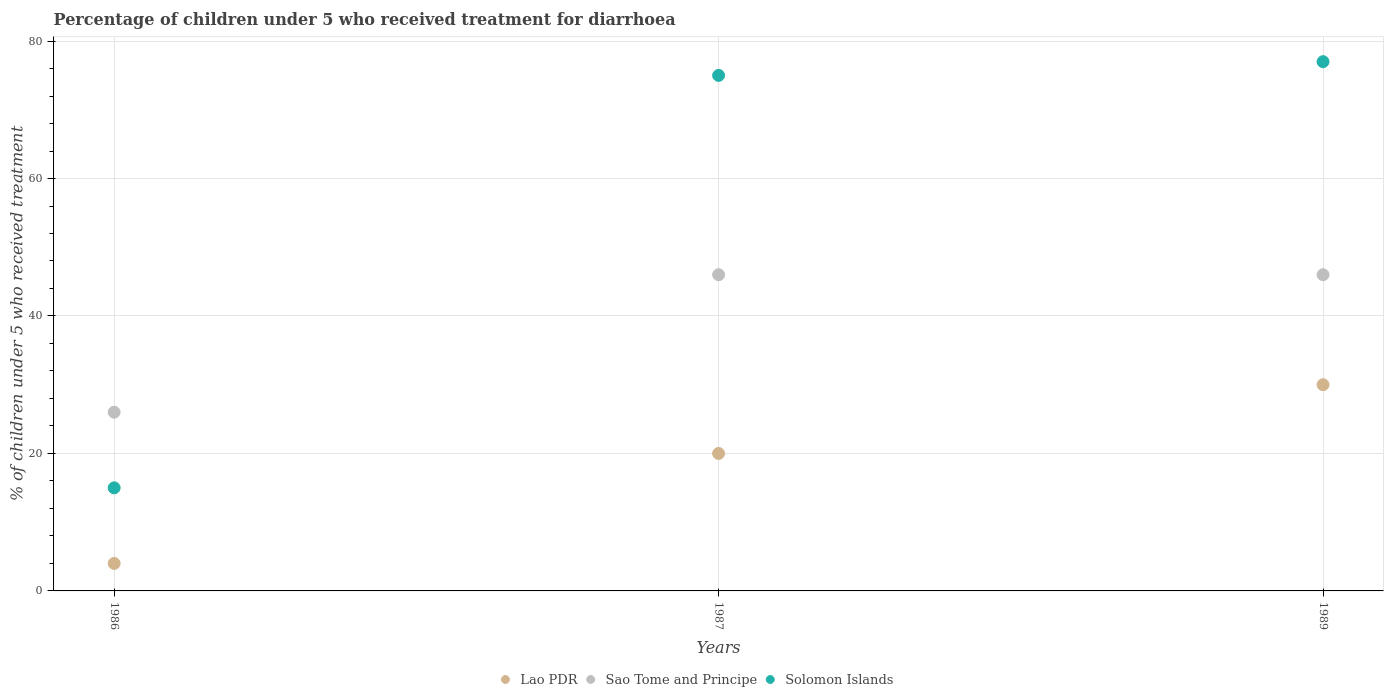How many different coloured dotlines are there?
Ensure brevity in your answer.  3. Is the number of dotlines equal to the number of legend labels?
Make the answer very short. Yes. What is the percentage of children who received treatment for diarrhoea  in Lao PDR in 1986?
Make the answer very short. 4. In which year was the percentage of children who received treatment for diarrhoea  in Sao Tome and Principe minimum?
Give a very brief answer. 1986. What is the total percentage of children who received treatment for diarrhoea  in Solomon Islands in the graph?
Your response must be concise. 167. What is the difference between the percentage of children who received treatment for diarrhoea  in Lao PDR in 1989 and the percentage of children who received treatment for diarrhoea  in Solomon Islands in 1987?
Offer a very short reply. -45. What is the average percentage of children who received treatment for diarrhoea  in Solomon Islands per year?
Your answer should be compact. 55.67. In the year 1986, what is the difference between the percentage of children who received treatment for diarrhoea  in Sao Tome and Principe and percentage of children who received treatment for diarrhoea  in Lao PDR?
Offer a terse response. 22. Is the difference between the percentage of children who received treatment for diarrhoea  in Sao Tome and Principe in 1986 and 1987 greater than the difference between the percentage of children who received treatment for diarrhoea  in Lao PDR in 1986 and 1987?
Provide a short and direct response. No. What is the difference between the highest and the lowest percentage of children who received treatment for diarrhoea  in Solomon Islands?
Ensure brevity in your answer.  62. In how many years, is the percentage of children who received treatment for diarrhoea  in Solomon Islands greater than the average percentage of children who received treatment for diarrhoea  in Solomon Islands taken over all years?
Provide a succinct answer. 2. Is the percentage of children who received treatment for diarrhoea  in Sao Tome and Principe strictly less than the percentage of children who received treatment for diarrhoea  in Lao PDR over the years?
Offer a very short reply. No. Are the values on the major ticks of Y-axis written in scientific E-notation?
Your answer should be compact. No. How are the legend labels stacked?
Provide a short and direct response. Horizontal. What is the title of the graph?
Your response must be concise. Percentage of children under 5 who received treatment for diarrhoea. What is the label or title of the X-axis?
Make the answer very short. Years. What is the label or title of the Y-axis?
Offer a very short reply. % of children under 5 who received treatment. What is the % of children under 5 who received treatment of Sao Tome and Principe in 1986?
Make the answer very short. 26. What is the % of children under 5 who received treatment in Solomon Islands in 1986?
Provide a succinct answer. 15. What is the % of children under 5 who received treatment of Lao PDR in 1987?
Your answer should be very brief. 20. What is the % of children under 5 who received treatment of Sao Tome and Principe in 1987?
Offer a very short reply. 46. What is the % of children under 5 who received treatment in Lao PDR in 1989?
Offer a very short reply. 30. Across all years, what is the maximum % of children under 5 who received treatment in Sao Tome and Principe?
Provide a succinct answer. 46. Across all years, what is the maximum % of children under 5 who received treatment in Solomon Islands?
Keep it short and to the point. 77. What is the total % of children under 5 who received treatment in Lao PDR in the graph?
Your answer should be very brief. 54. What is the total % of children under 5 who received treatment of Sao Tome and Principe in the graph?
Keep it short and to the point. 118. What is the total % of children under 5 who received treatment in Solomon Islands in the graph?
Offer a very short reply. 167. What is the difference between the % of children under 5 who received treatment of Sao Tome and Principe in 1986 and that in 1987?
Provide a succinct answer. -20. What is the difference between the % of children under 5 who received treatment in Solomon Islands in 1986 and that in 1987?
Your answer should be very brief. -60. What is the difference between the % of children under 5 who received treatment in Lao PDR in 1986 and that in 1989?
Provide a succinct answer. -26. What is the difference between the % of children under 5 who received treatment in Solomon Islands in 1986 and that in 1989?
Provide a succinct answer. -62. What is the difference between the % of children under 5 who received treatment of Sao Tome and Principe in 1987 and that in 1989?
Provide a succinct answer. 0. What is the difference between the % of children under 5 who received treatment of Solomon Islands in 1987 and that in 1989?
Offer a terse response. -2. What is the difference between the % of children under 5 who received treatment in Lao PDR in 1986 and the % of children under 5 who received treatment in Sao Tome and Principe in 1987?
Ensure brevity in your answer.  -42. What is the difference between the % of children under 5 who received treatment of Lao PDR in 1986 and the % of children under 5 who received treatment of Solomon Islands in 1987?
Your response must be concise. -71. What is the difference between the % of children under 5 who received treatment of Sao Tome and Principe in 1986 and the % of children under 5 who received treatment of Solomon Islands in 1987?
Give a very brief answer. -49. What is the difference between the % of children under 5 who received treatment of Lao PDR in 1986 and the % of children under 5 who received treatment of Sao Tome and Principe in 1989?
Your response must be concise. -42. What is the difference between the % of children under 5 who received treatment of Lao PDR in 1986 and the % of children under 5 who received treatment of Solomon Islands in 1989?
Provide a short and direct response. -73. What is the difference between the % of children under 5 who received treatment in Sao Tome and Principe in 1986 and the % of children under 5 who received treatment in Solomon Islands in 1989?
Provide a short and direct response. -51. What is the difference between the % of children under 5 who received treatment of Lao PDR in 1987 and the % of children under 5 who received treatment of Solomon Islands in 1989?
Offer a terse response. -57. What is the difference between the % of children under 5 who received treatment of Sao Tome and Principe in 1987 and the % of children under 5 who received treatment of Solomon Islands in 1989?
Provide a succinct answer. -31. What is the average % of children under 5 who received treatment of Lao PDR per year?
Provide a short and direct response. 18. What is the average % of children under 5 who received treatment in Sao Tome and Principe per year?
Provide a short and direct response. 39.33. What is the average % of children under 5 who received treatment of Solomon Islands per year?
Your answer should be compact. 55.67. In the year 1986, what is the difference between the % of children under 5 who received treatment of Lao PDR and % of children under 5 who received treatment of Sao Tome and Principe?
Make the answer very short. -22. In the year 1986, what is the difference between the % of children under 5 who received treatment in Lao PDR and % of children under 5 who received treatment in Solomon Islands?
Your response must be concise. -11. In the year 1987, what is the difference between the % of children under 5 who received treatment in Lao PDR and % of children under 5 who received treatment in Solomon Islands?
Offer a very short reply. -55. In the year 1989, what is the difference between the % of children under 5 who received treatment in Lao PDR and % of children under 5 who received treatment in Solomon Islands?
Offer a very short reply. -47. In the year 1989, what is the difference between the % of children under 5 who received treatment of Sao Tome and Principe and % of children under 5 who received treatment of Solomon Islands?
Provide a short and direct response. -31. What is the ratio of the % of children under 5 who received treatment in Sao Tome and Principe in 1986 to that in 1987?
Your answer should be very brief. 0.57. What is the ratio of the % of children under 5 who received treatment of Solomon Islands in 1986 to that in 1987?
Your answer should be very brief. 0.2. What is the ratio of the % of children under 5 who received treatment in Lao PDR in 1986 to that in 1989?
Provide a succinct answer. 0.13. What is the ratio of the % of children under 5 who received treatment in Sao Tome and Principe in 1986 to that in 1989?
Your response must be concise. 0.57. What is the ratio of the % of children under 5 who received treatment in Solomon Islands in 1986 to that in 1989?
Your answer should be compact. 0.19. What is the ratio of the % of children under 5 who received treatment in Sao Tome and Principe in 1987 to that in 1989?
Your response must be concise. 1. What is the difference between the highest and the second highest % of children under 5 who received treatment of Lao PDR?
Give a very brief answer. 10. What is the difference between the highest and the second highest % of children under 5 who received treatment of Sao Tome and Principe?
Offer a very short reply. 0. What is the difference between the highest and the second highest % of children under 5 who received treatment in Solomon Islands?
Your answer should be very brief. 2. What is the difference between the highest and the lowest % of children under 5 who received treatment of Lao PDR?
Offer a very short reply. 26. What is the difference between the highest and the lowest % of children under 5 who received treatment of Sao Tome and Principe?
Make the answer very short. 20. What is the difference between the highest and the lowest % of children under 5 who received treatment in Solomon Islands?
Your response must be concise. 62. 